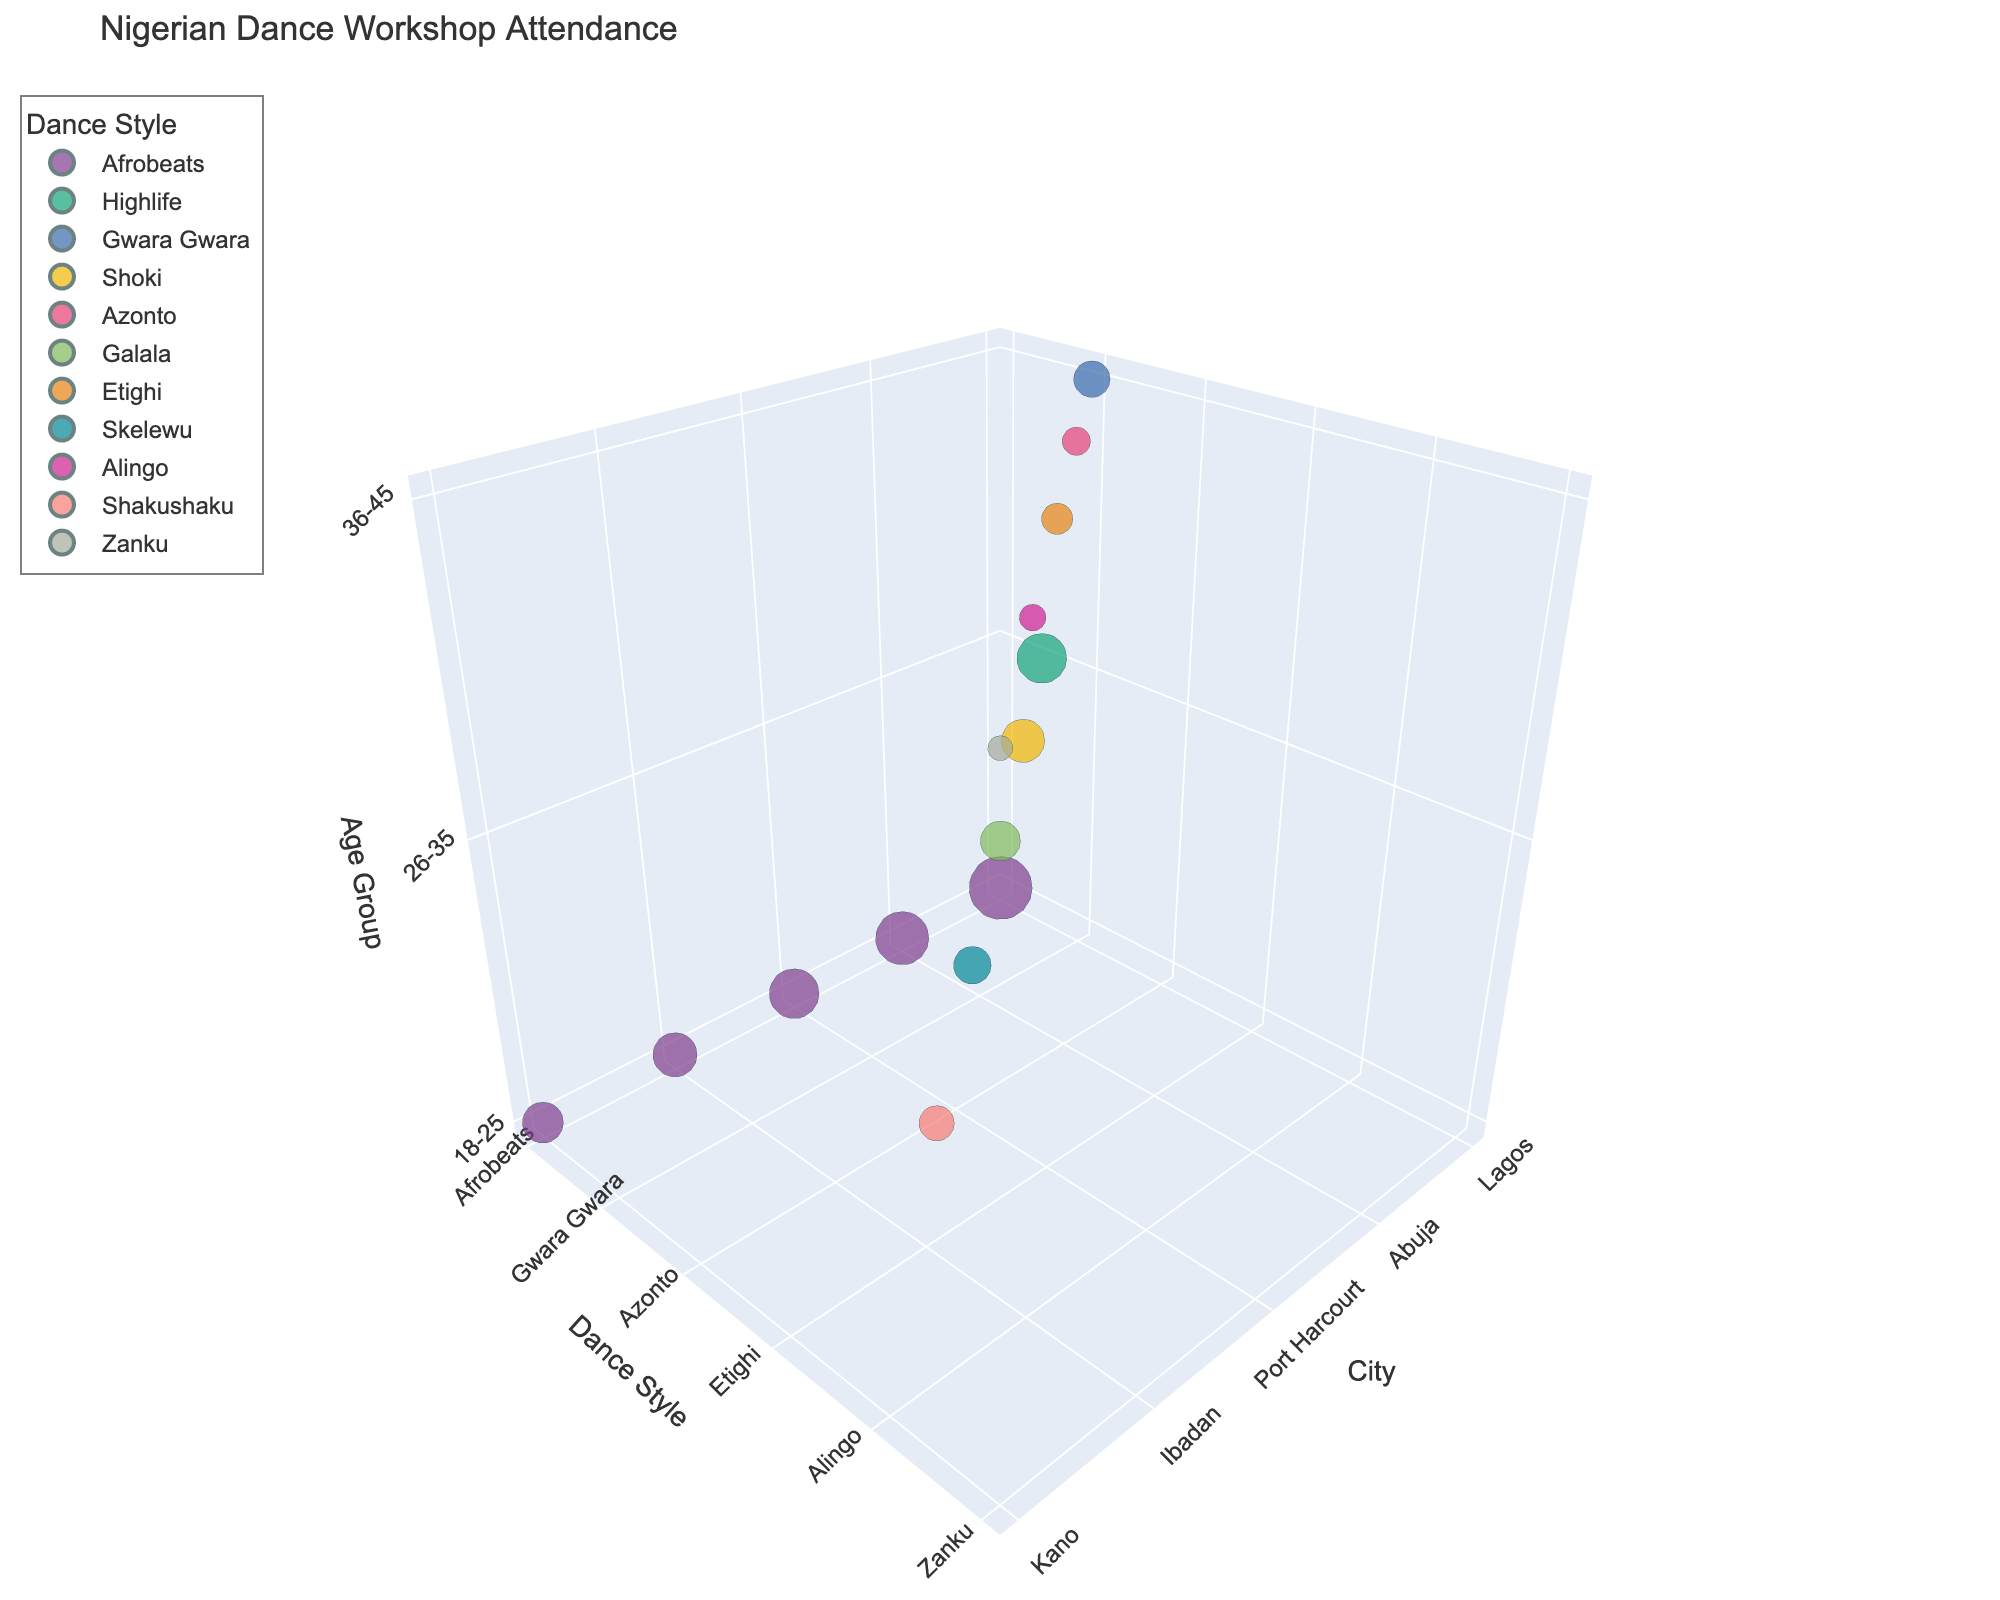Which city has the highest attendance for the 18-25 age group? Look at the bubbles on the z-axis labeled "18-25" and compare their sizes. The largest bubble represents the highest attendance. Lagos has the highest attendance with a bubble size indicating 450.
Answer: Lagos Which dance style in Abuja has the lowest attendance? Identify the bubbles for Abuja and compare their sizes across different dance styles. The smallest bubble corresponds to Azonto with an attendance of 90.
Answer: Azonto What is the total attendance for Afrobeats across all cities? Find all bubbles representing Afrobeats in different cities and sum their values: Lagos (450), Abuja (320), Port Harcourt (280), Ibadan (220), and Kano (190). The total is 450 + 320 + 280 + 220 + 190 = 1460.
Answer: 1460 Comparing Lagos and Abuja, which city has higher attendance across all dance styles? Add up the total attendance values for all dance styles for each city. Lagos: 450 (Afrobeats) + 280 (Highlife) + 150 (Gwara Gwara) = 880. Abuja: 320 (Afrobeats) + 210 (Shoki) + 90 (Azonto) = 620. Lagos has a higher total attendance.
Answer: Lagos Which age group has the least attendance in Port Harcourt? Look at the bubbles for Port Harcourt and identify the smallest one. The smallest bubble corresponds to the 36-45 age group with an attendance of 110.
Answer: 36-45 Which dance style has the highest variation in attendance across different cities? Compare the size differences of bubbles for each dance style across cities. Afrobeats show the largest variation because it ranges from 190 in Kano to 450 in Lagos.
Answer: Afrobeats By how much does the Afrobeats attendance in Lagos exceed that in Ibadan? Look at the bubbles for Afrobeats in Lagos and Ibadan and subtract the smaller value from the larger: 450 (Lagos) - 220 (Ibadan) = 230.
Answer: 230 Which city has the smallest total attendance for the 36-45 age group? Add up the attendance values for the 36-45 age group in each city. Lagos: 150, Abuja: 90, Port Harcourt: 110, Ibadan: 80, Kano: 70. Kano has the smallest total attendance with 70.
Answer: Kano What's the ratio of attendance between the 18-25 and 26-35 age groups in Port Harcourt? Find the attendance values for the respective age groups in Port Harcourt and divide the larger by the smaller: 280 (18-25) / 180 (26-35) = 1.56.
Answer: 1.56 